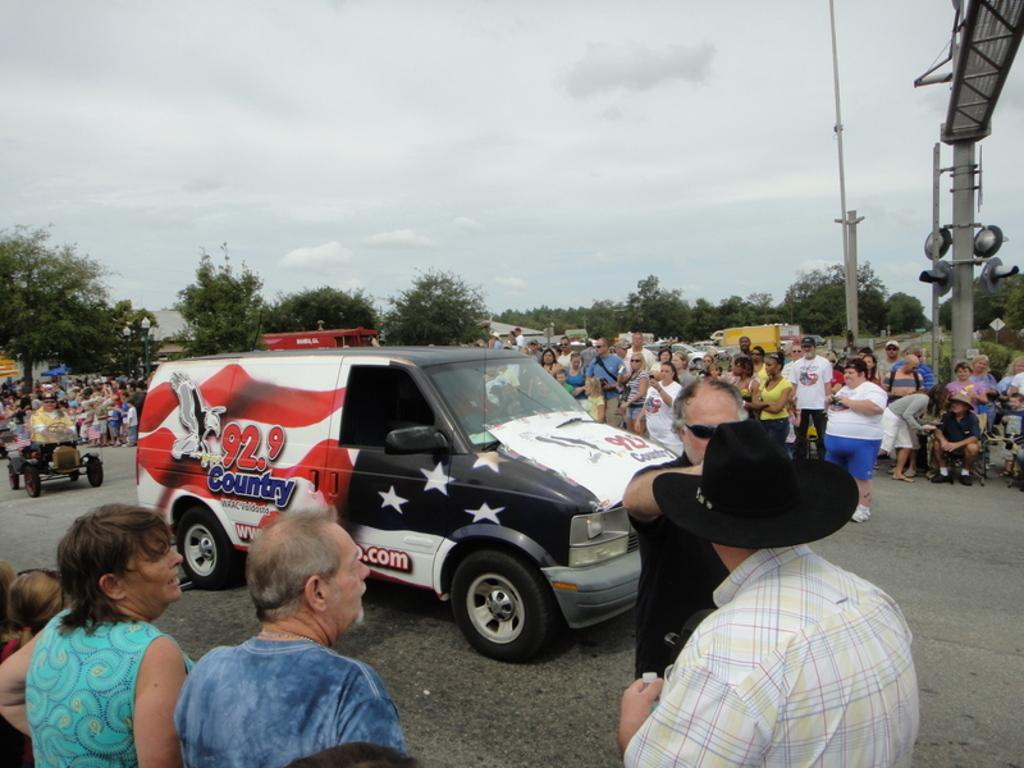What is happening in the image? There is a group of people standing in the image. Can you describe the vehicle in the image? The vehicle in the image has white, red, and black colors. What can be seen in the background of the image? There are trees with green colors and the sky with white colors in the background of the image. What type of lawyer is depicted in the image? There is no lawyer present in the image. Can you describe the jar that is being used to whip the cream in the image? There is no jar or whipping of cream present in the image. 